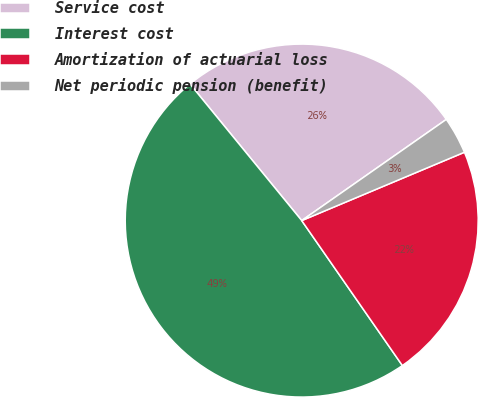Convert chart. <chart><loc_0><loc_0><loc_500><loc_500><pie_chart><fcel>Service cost<fcel>Interest cost<fcel>Amortization of actuarial loss<fcel>Net periodic pension (benefit)<nl><fcel>26.2%<fcel>48.75%<fcel>21.67%<fcel>3.39%<nl></chart> 